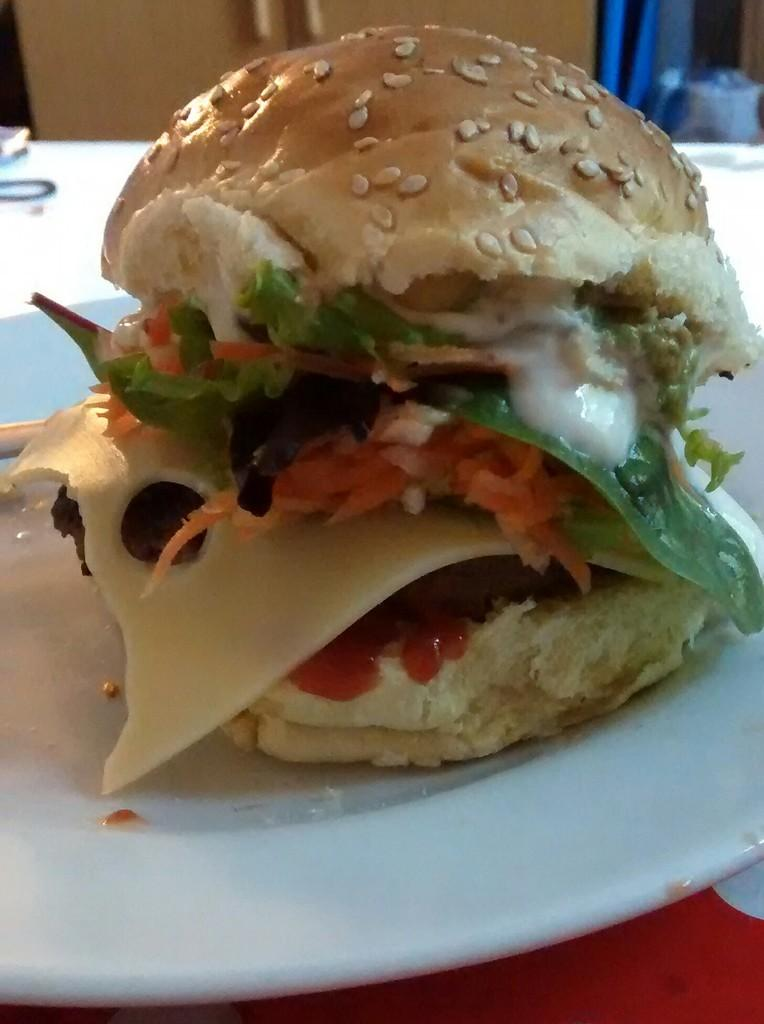Where was the image taken? The image is taken indoors. What can be seen in the background of the image? There is a wall in the background of the image. What piece of furniture is at the bottom of the image? There is a table at the bottom of the image. What is on the table in the image? There is a plate on the table. What is on the plate in the image? There is a burger on the plate. What type of bath can be seen in the image? There is no bath present in the image; it features a burger on a plate. Can you provide an example of a son in the image? There is no person, let alone a son, present in the image. 